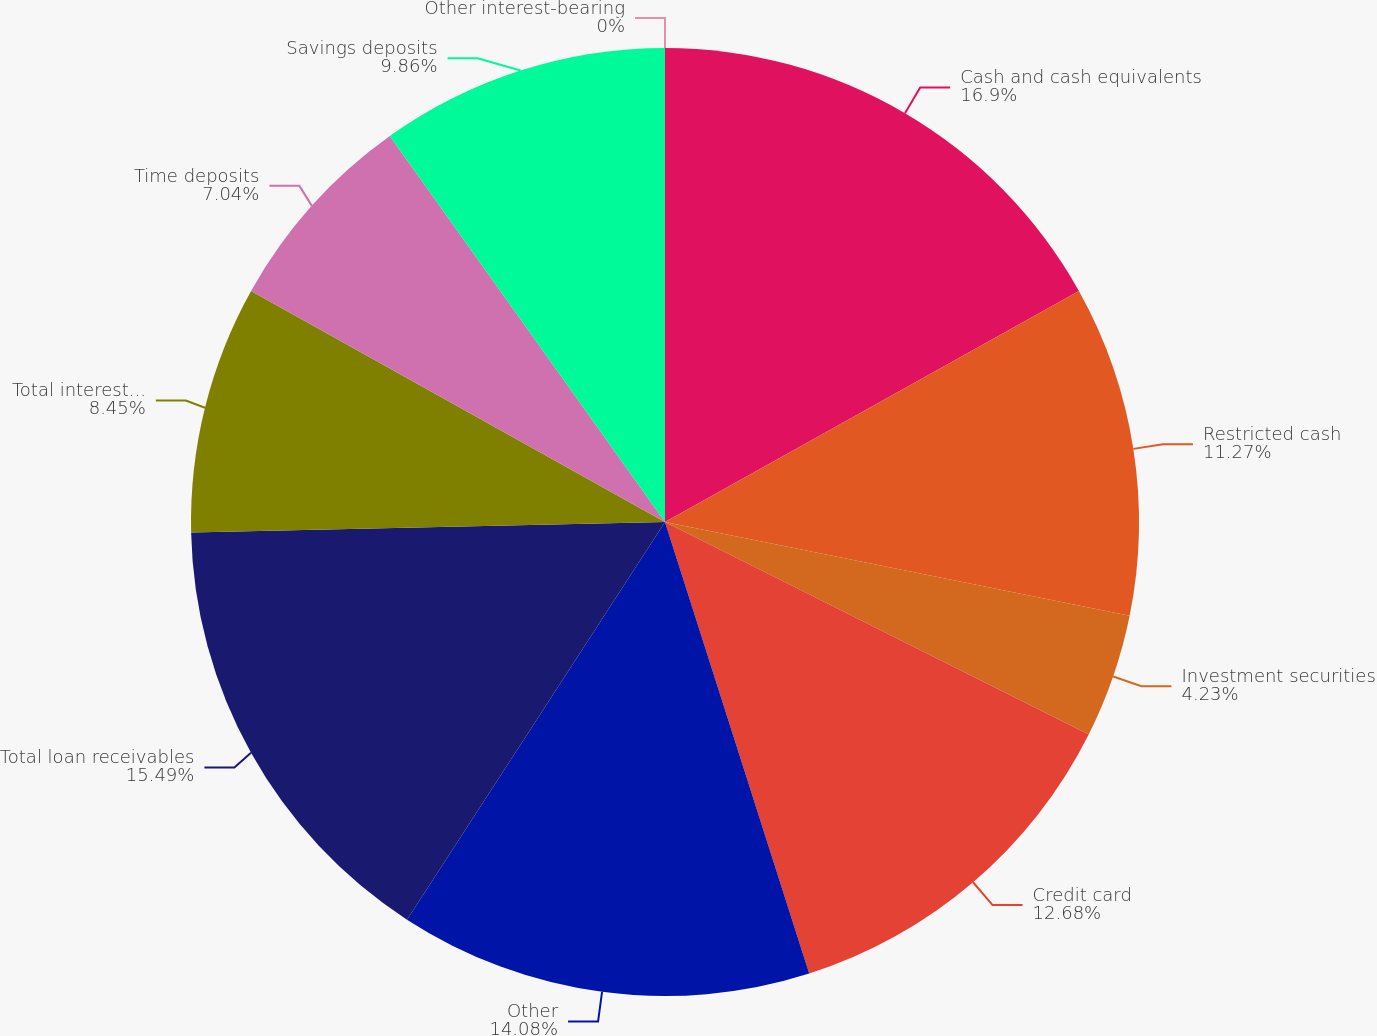Convert chart. <chart><loc_0><loc_0><loc_500><loc_500><pie_chart><fcel>Cash and cash equivalents<fcel>Restricted cash<fcel>Investment securities<fcel>Credit card<fcel>Other<fcel>Total loan receivables<fcel>Total interest income<fcel>Time deposits<fcel>Savings deposits<fcel>Other interest-bearing<nl><fcel>16.9%<fcel>11.27%<fcel>4.23%<fcel>12.68%<fcel>14.08%<fcel>15.49%<fcel>8.45%<fcel>7.04%<fcel>9.86%<fcel>0.0%<nl></chart> 